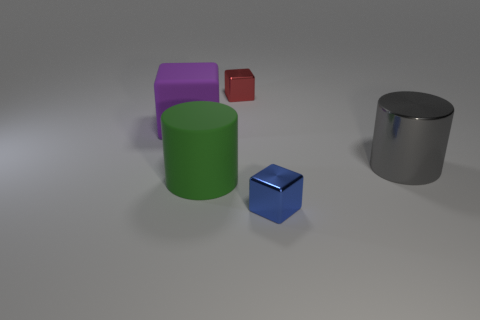Is the shape of the large purple thing the same as the green matte thing?
Your answer should be compact. No. What is the size of the thing that is on the left side of the red block and in front of the big gray thing?
Your answer should be very brief. Large. How many green rubber things are right of the gray metal thing?
Offer a very short reply. 0. What shape is the shiny thing that is both behind the green matte thing and in front of the small red metallic block?
Give a very brief answer. Cylinder. How many cylinders are either cyan shiny objects or small metal things?
Your answer should be very brief. 0. Is the number of small things that are behind the big purple rubber object less than the number of big gray blocks?
Your response must be concise. No. What is the color of the thing that is both behind the green cylinder and on the left side of the red metal cube?
Keep it short and to the point. Purple. What number of other things are the same shape as the red thing?
Provide a short and direct response. 2. Are there fewer blue cubes to the right of the large gray metal object than big gray objects that are on the right side of the red metallic block?
Offer a very short reply. Yes. Are the blue block and the red object to the right of the purple matte object made of the same material?
Give a very brief answer. Yes. 